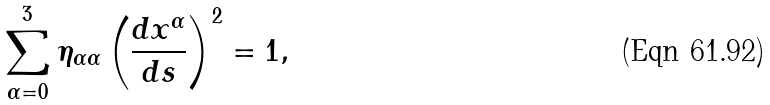Convert formula to latex. <formula><loc_0><loc_0><loc_500><loc_500>\sum _ { \alpha = 0 } ^ { 3 } \eta _ { \alpha \alpha } \left ( \frac { d x ^ { \alpha } } { d s } \right ) ^ { 2 } = 1 ,</formula> 